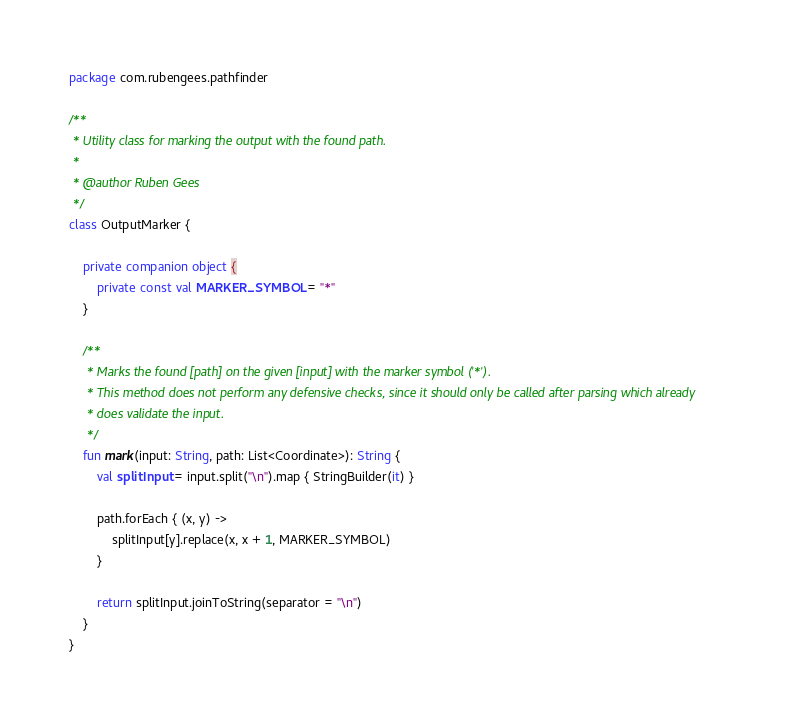Convert code to text. <code><loc_0><loc_0><loc_500><loc_500><_Kotlin_>package com.rubengees.pathfinder

/**
 * Utility class for marking the output with the found path.
 *
 * @author Ruben Gees
 */
class OutputMarker {

    private companion object {
        private const val MARKER_SYMBOL = "*"
    }

    /**
     * Marks the found [path] on the given [input] with the marker symbol ('*').
     * This method does not perform any defensive checks, since it should only be called after parsing which already
     * does validate the input.
     */
    fun mark(input: String, path: List<Coordinate>): String {
        val splitInput = input.split("\n").map { StringBuilder(it) }

        path.forEach { (x, y) ->
            splitInput[y].replace(x, x + 1, MARKER_SYMBOL)
        }

        return splitInput.joinToString(separator = "\n")
    }
}
</code> 